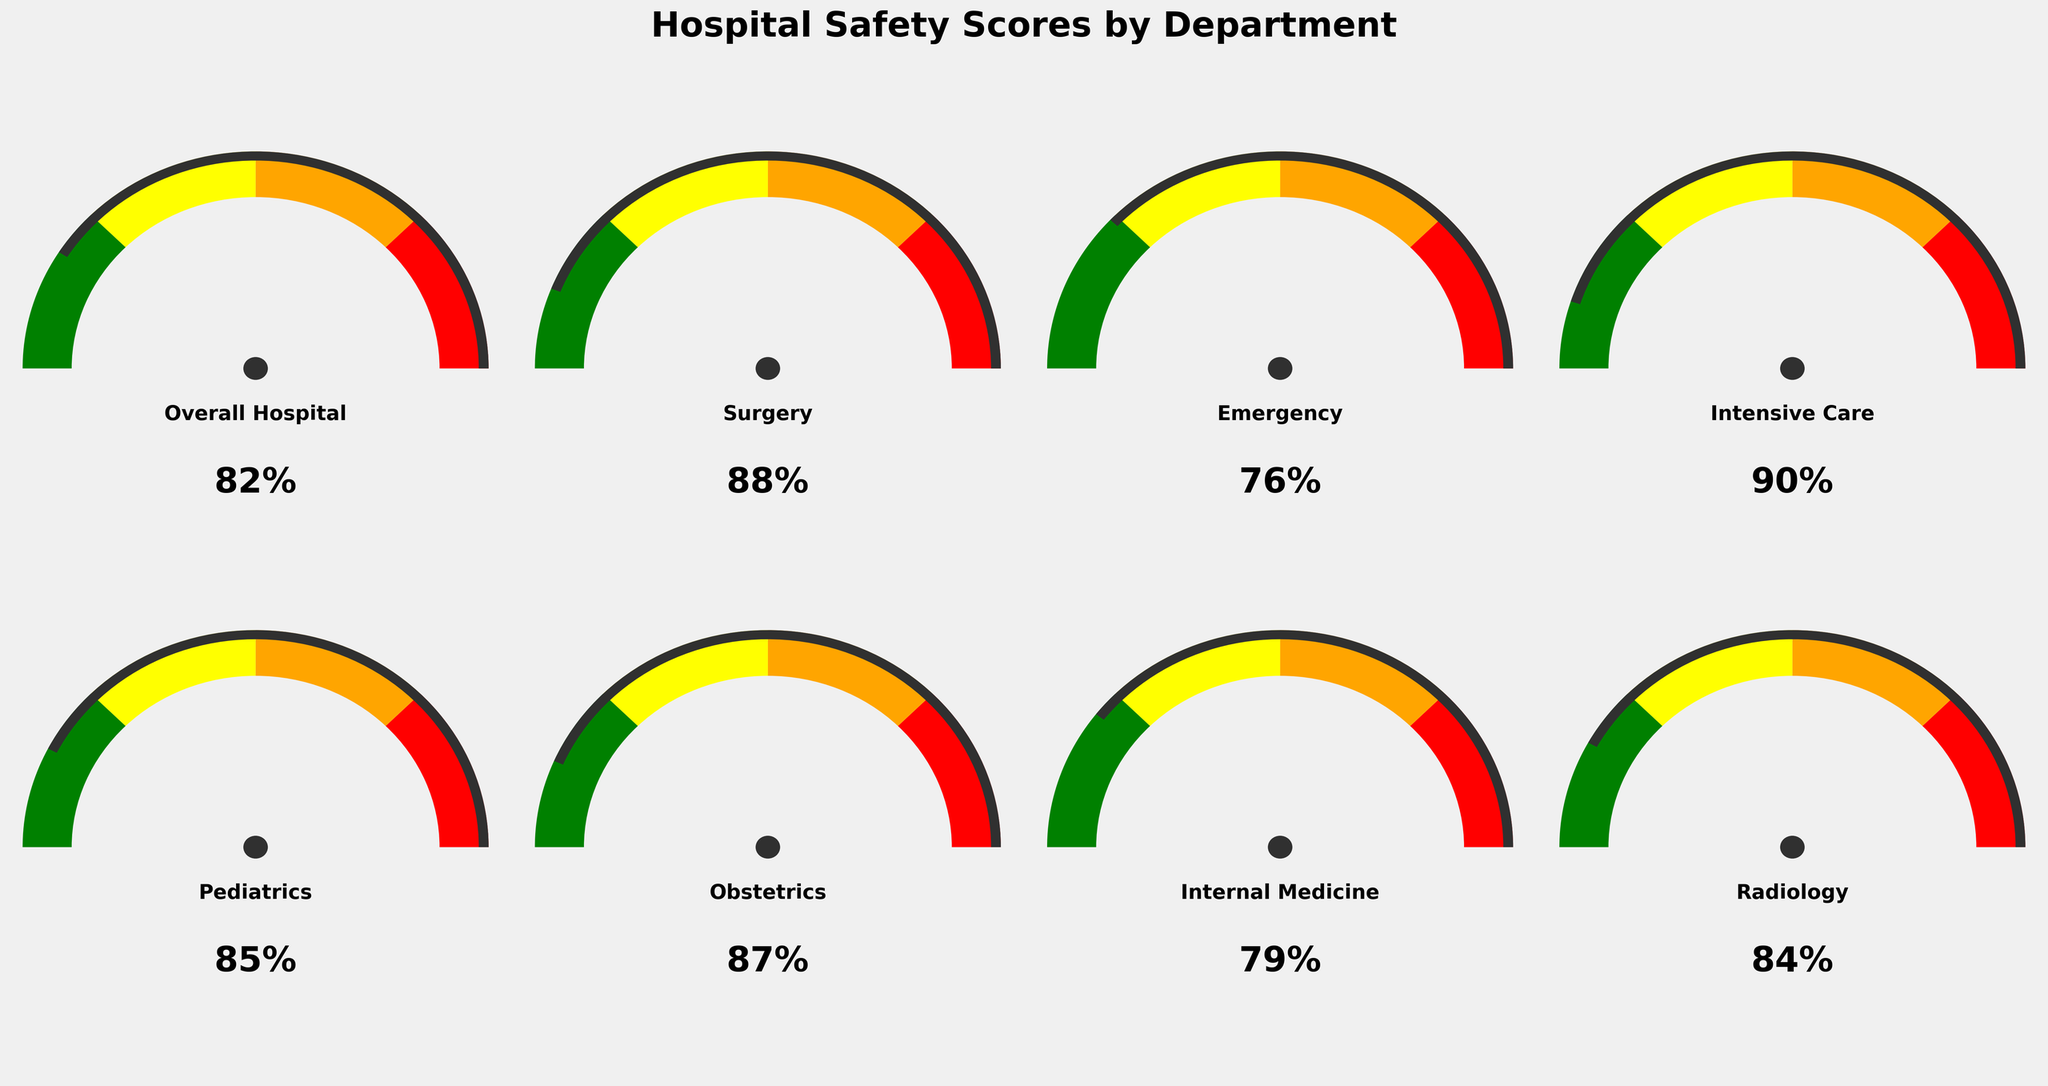What is the overall patient safety score for the hospital? The overall patient safety score is displayed in the "Overall Hospital" gauge in the middle of the top row. The value indicated is 82%.
Answer: 82% Which department has the highest patient safety score? By comparing all the departments' scores, the Intensive Care department has the highest score of 90%.
Answer: Intensive Care How much higher is the Surgery department's safety score compared to the Emergency department's score? The Surgery department has a score of 88%, and the Emergency department has a score of 76%. The difference between these scores is calculated as 88% - 76% = 12%.
Answer: 12% What color section represents the highest safety score range in the gauge chart, and which department falls into this range? The highest safety score range is represented by the green section. Both the Intensive Care (90%) and Surgery (88%) departments fall into this green section.
Answer: Green; Intensive Care and Surgery What is the average patient safety score across all departments? To find the average score, add up the scores of all departments: (82 + 88 + 76 + 90 + 85 + 87 + 79 + 84) = 671. Then, divide by the number of departments (8): 671 / 8 = 83.875%.
Answer: 83.875% Which department has the lowest patient safety score, and what is that score? By comparing all the departments' scores, the Emergency department has the lowest score of 76%.
Answer: Emergency; 76% Is Pediatrics' safety score below or above the overall hospital safety score? The Pediatrics department's score is 85%, while the overall hospital score is 82%. Since 85% is greater than 82%, the Pediatrics score is above the overall score.
Answer: Above Which two departments have safety scores closest to each other, and what are those scores? By comparing the differences between each department's scores, Pediatrics (85%) and Obstetrics (87%) have the closest scores with a difference of 2%.
Answer: Pediatrics (85%) and Obstetrics (87%) Is Radiology's patient safety score in the yellow or green range? Radiology has a safety score of 84%. Based on the color coding (red, orange, yellow, green), a score of 84% falls within the green range.
Answer: Green How many departments have safety scores equal to or above 85%? By examining the scores, the departments that have scores equal to or above 85% are Surgery (88%), Intensive Care (90%), Pediatrics (85%), Obstetrics (87%), and Radiology (84%). This is a total of 5 departments.
Answer: 5 